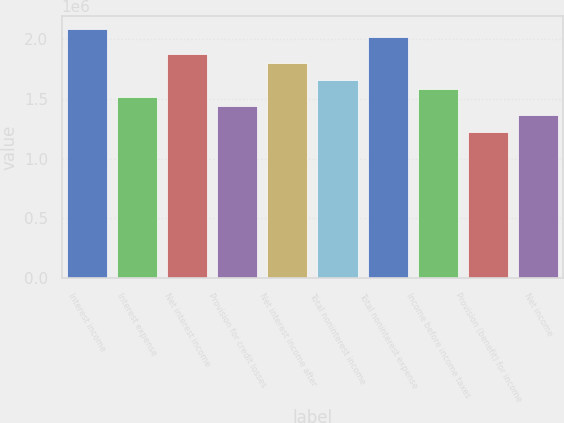<chart> <loc_0><loc_0><loc_500><loc_500><bar_chart><fcel>Interest income<fcel>Interest expense<fcel>Net interest income<fcel>Provision for credit losses<fcel>Net interest income after<fcel>Total noninterest income<fcel>Total noninterest expense<fcel>Income before income taxes<fcel>Provision (benefit) for income<fcel>Net income<nl><fcel>2.08674e+06<fcel>1.51109e+06<fcel>1.87087e+06<fcel>1.43913e+06<fcel>1.79892e+06<fcel>1.655e+06<fcel>2.01479e+06<fcel>1.58305e+06<fcel>1.22326e+06<fcel>1.36718e+06<nl></chart> 